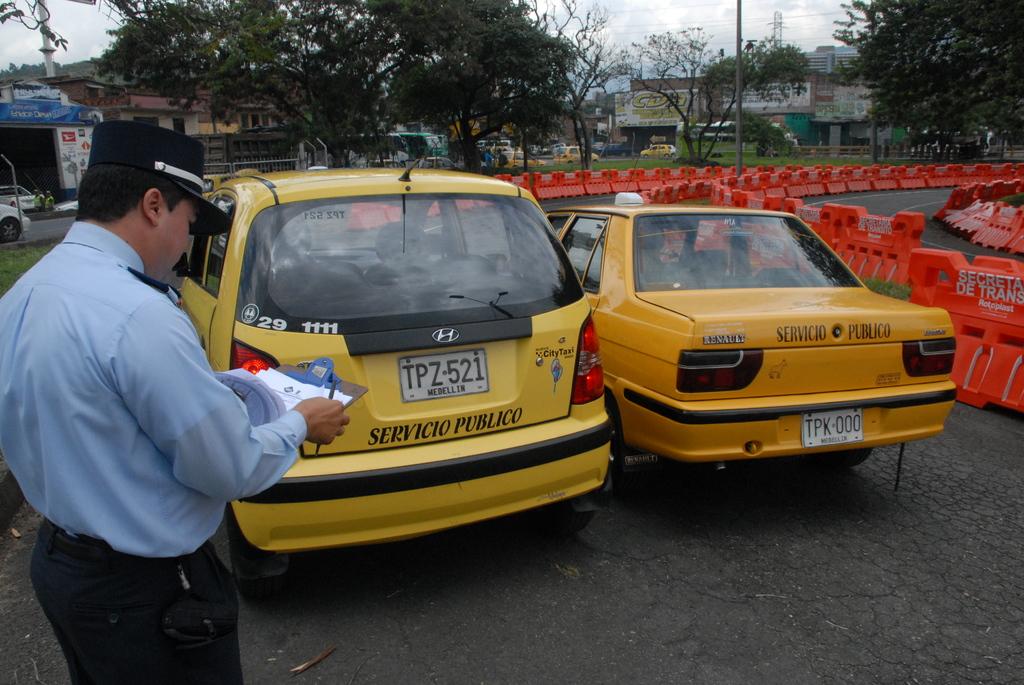What is the license plate on the orange vehicle?
Your answer should be very brief. Tpk 000. What is plate number for yellow car on left?
Offer a terse response. Tpz-521. 